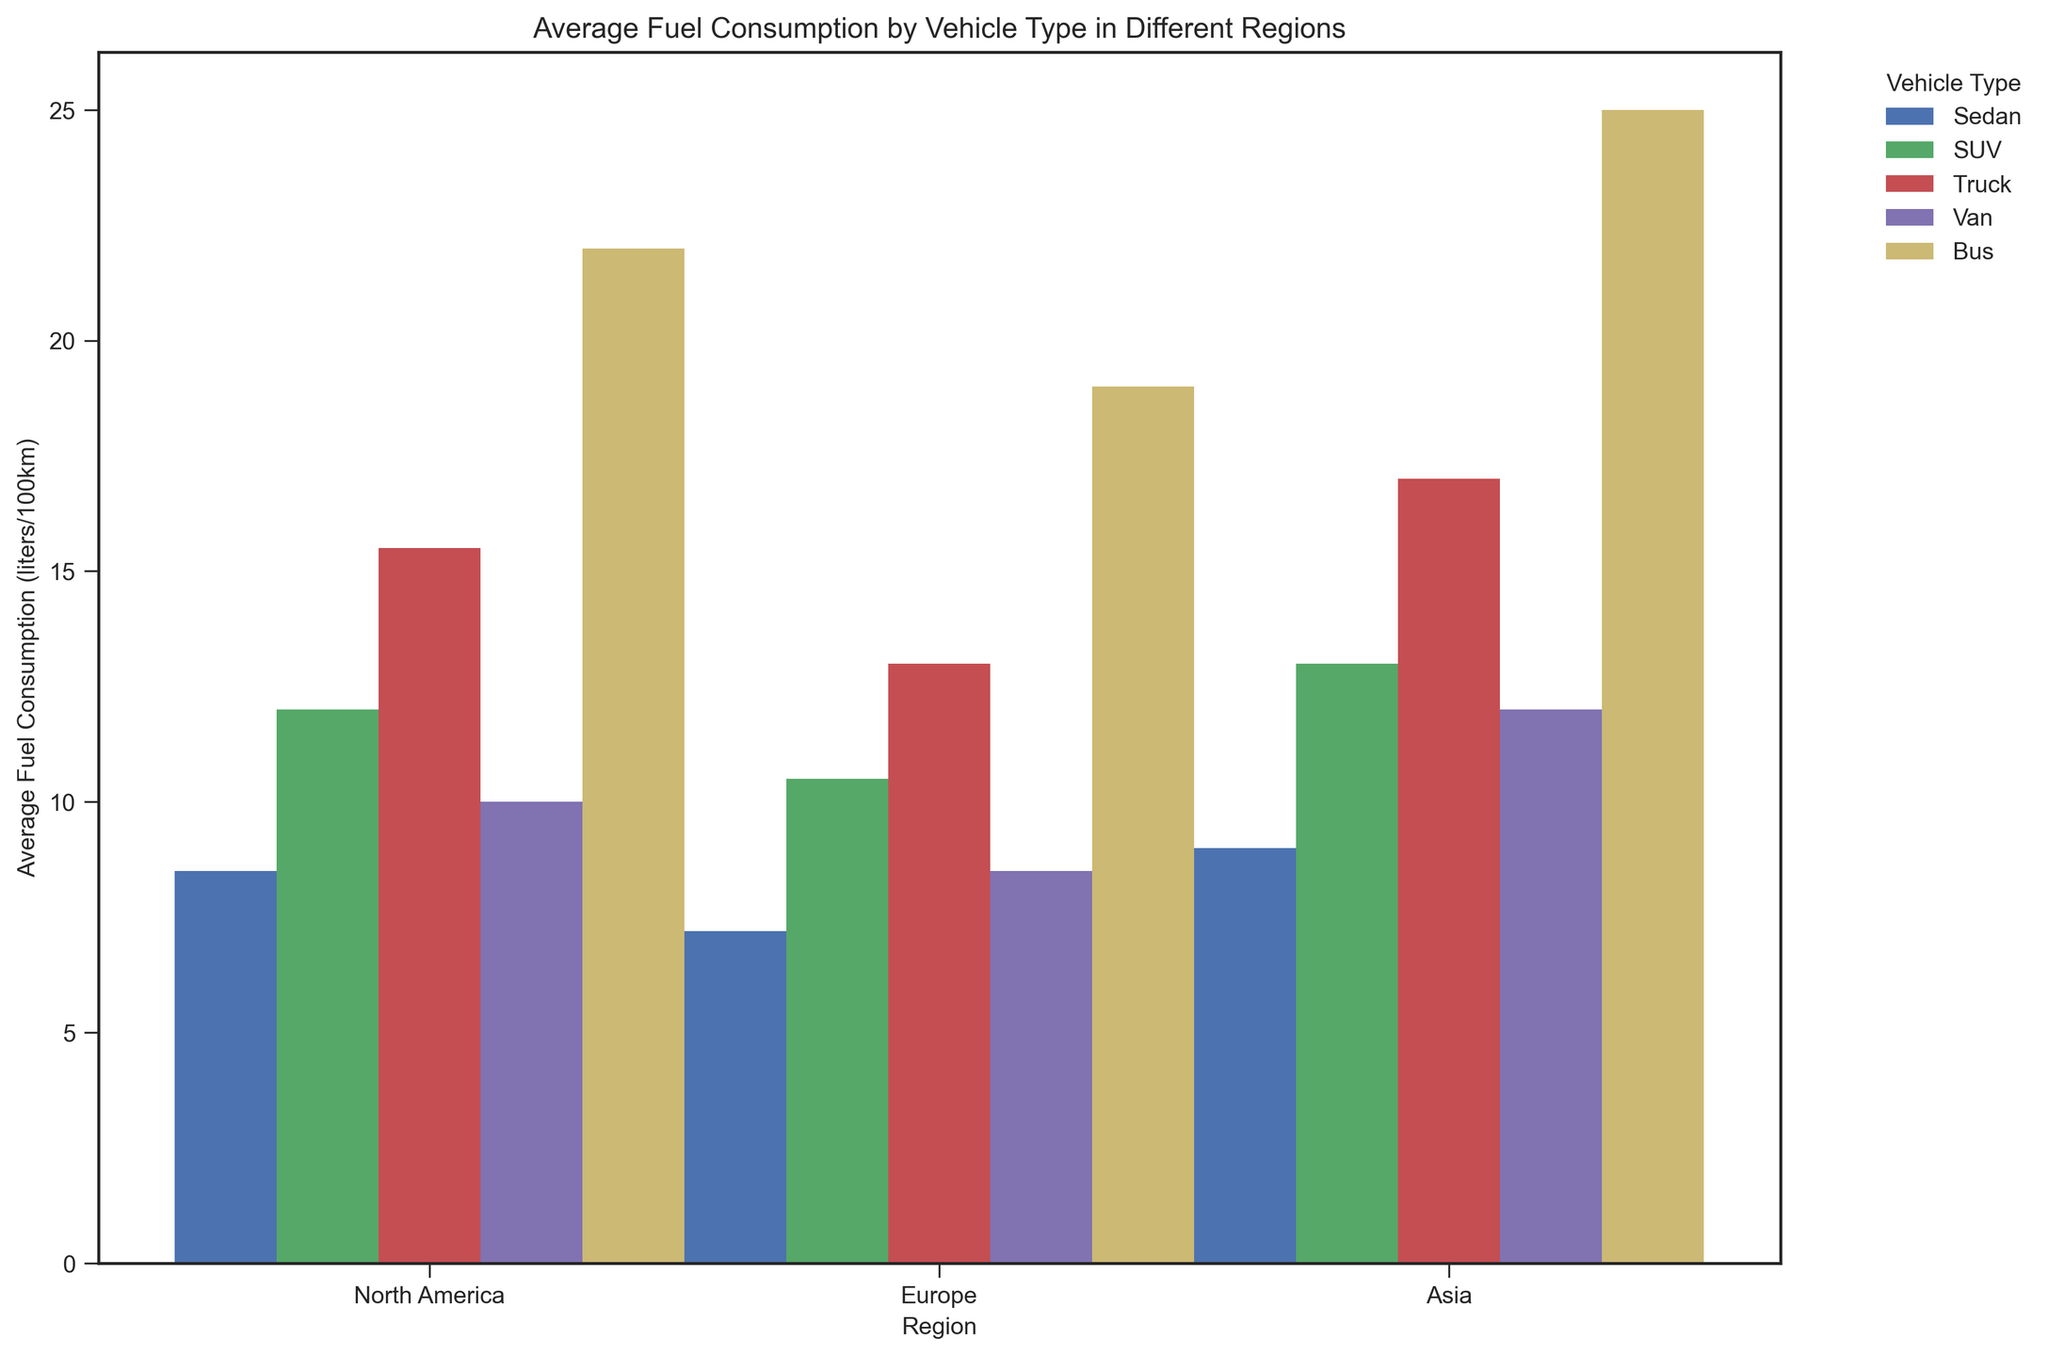What is the region with the highest average fuel consumption for SUVs? First, identify the average fuel consumption for SUVs in each region by locating the bars in the SUV category. The values are 12.0 for North America, 10.5 for Europe, and 13.0 for Asia. Asia has the highest value among these.
Answer: Asia Which vehicle type has the lowest average fuel consumption in Europe? Look at the bars corresponding to each vehicle type in the Europe section and compare their heights. The values are Sedan (7.2), SUV (10.5), Truck (13.0), Van (8.5), and Bus (19.0). The smallest value is for Sedan.
Answer: Sedan Which region shows the largest difference in fuel consumption between Trucks and Vans? Calculate the differences in fuel consumption between Trucks and Vans in each region. North America: 15.5 - 10.0 = 5.5, Europe: 13.0 - 8.5 = 4.5, Asia: 17.0 - 12.0 = 5. The largest difference is in North America.
Answer: North America What is the average fuel consumption of all vehicle types in North America? Sum up the average fuel consumption values for all vehicle types in North America: Sedan (8.5), SUV (12.0), Truck (15.5), Van (10.0), Bus (22.0). The sum is 8.5 + 12.0 + 15.5 + 10.0 + 22.0 = 68. Then, divide by the number of vehicle types (5). So, 68 / 5 = 13.6.
Answer: 13.6 Which vehicle type exhibits the greatest variance in average fuel consumption across different regions? Calculate the variance by finding the differences between the maximum and minimum averages of each vehicle type across the regions. For Sedan, values are 8.5, 7.2, and 9.0, resulting in a range of 9.0 - 7.2 = 1.8. For SUV, values are 12.0, 10.5, and 13.0, range = 13.0 - 10.5 = 2.5. For Truck, values are 15.5, 13.0, and 17.0, range = 17.0 - 13.0 = 4.0. For Van, values are 10.0, 8.5, and 12.0, range = 12.0 - 8.5 = 3.5. For Bus, values are 22.0, 19.0, and 25.0, range = 25.0 - 19.0 = 6.0. The greatest variance is in the Bus category.
Answer: Bus If you average the fuel consumption of SUVs and Buses across all regions, which one is higher? Calculate the overall average for SUVs and Buses. For SUVs: (12.0 [NA] + 10.5 [EU] + 13.0 [Asia]) / 3 = 11.83. For Buses: (22.0 [NA] + 19.0 [EU] + 25.0 [Asia]) / 3 = 22.0. Buses have a higher average.
Answer: Buses Between North America and Europe, which region has higher average fuel consumption for Vans? Compare the average fuel consumption for Vans in North America (10.0) and in Europe (8.5). North America has the higher value.
Answer: North America What is the cumulative fuel consumption of all vehicle types in Asia? Sum up the average fuel consumption values for all vehicle types in Asia: Sedan (9.0), SUV (13.0), Truck (17.0), Van (12.0), Bus (25.0). The sum is 9.0 + 13.0 + 17.0 + 12.0 + 25.0 = 76.0.
Answer: 76.0 